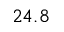Convert formula to latex. <formula><loc_0><loc_0><loc_500><loc_500>2 4 . 8</formula> 